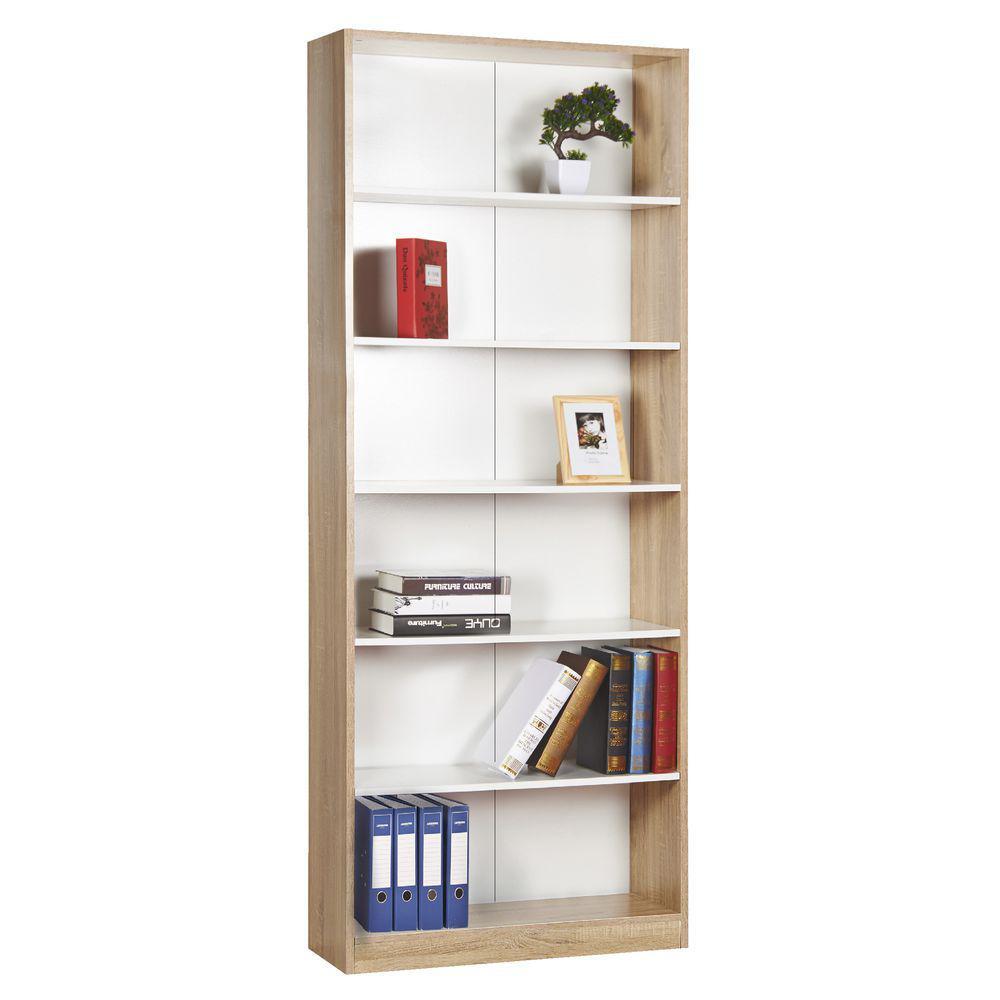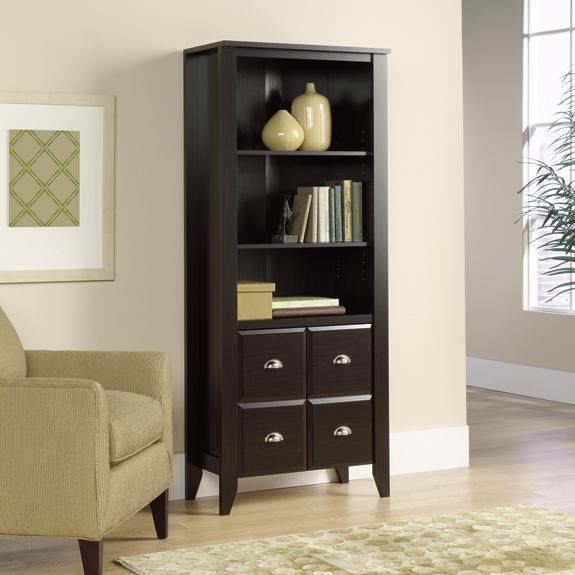The first image is the image on the left, the second image is the image on the right. For the images displayed, is the sentence "One tall narrow bookcase is on short legs and one is flush to the floor." factually correct? Answer yes or no. Yes. 